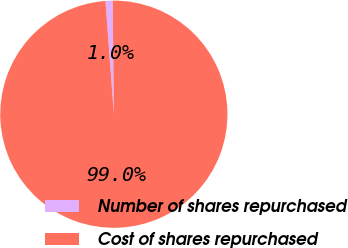Convert chart. <chart><loc_0><loc_0><loc_500><loc_500><pie_chart><fcel>Number of shares repurchased<fcel>Cost of shares repurchased<nl><fcel>1.01%<fcel>98.99%<nl></chart> 